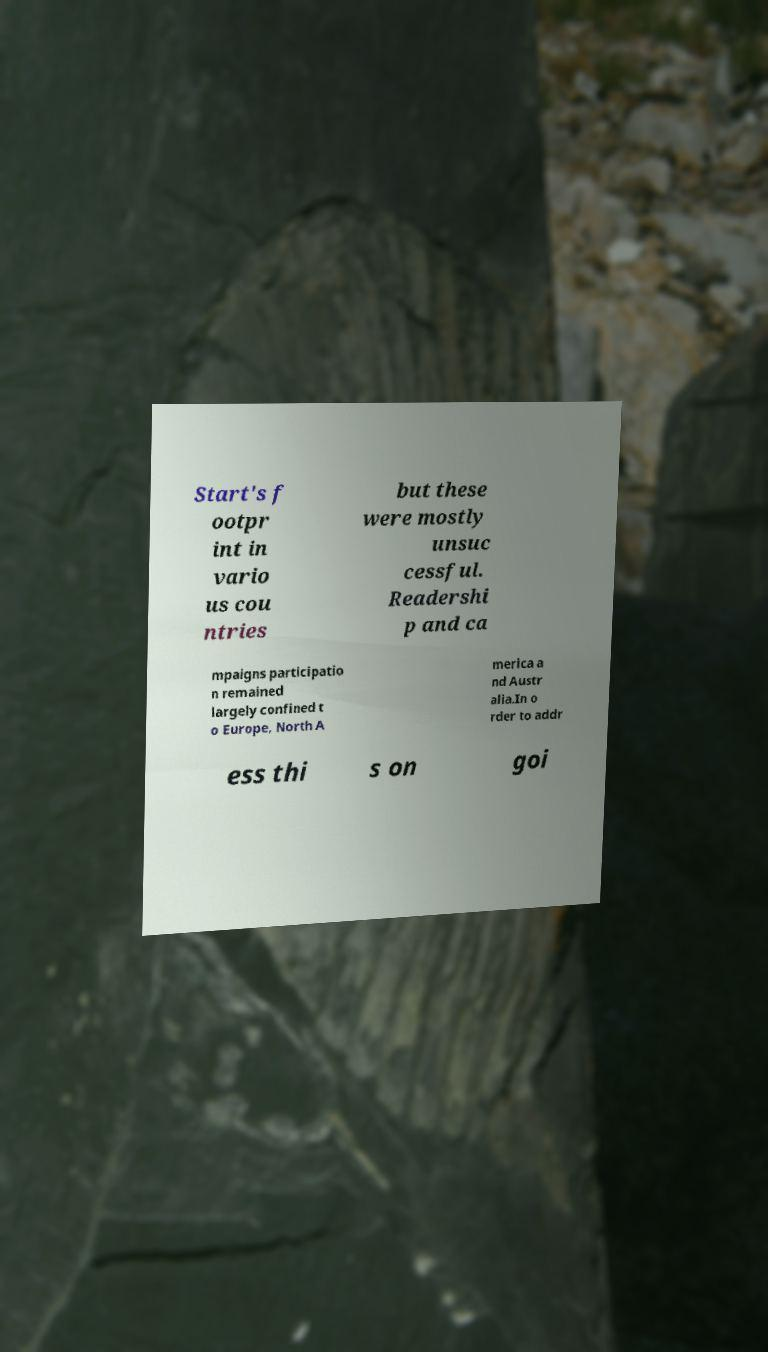Please identify and transcribe the text found in this image. Start's f ootpr int in vario us cou ntries but these were mostly unsuc cessful. Readershi p and ca mpaigns participatio n remained largely confined t o Europe, North A merica a nd Austr alia.In o rder to addr ess thi s on goi 